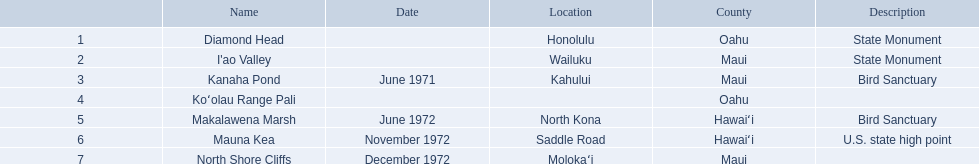What are the names of every landmark? Diamond Head, I'ao Valley, Kanaha Pond, Koʻolau Range Pali, Makalawena Marsh, Mauna Kea, North Shore Cliffs. In which places are they situated? Honolulu, Wailuku, Kahului, , North Kona, Saddle Road, Molokaʻi. And which landmark lacks a listed location? Koʻolau Range Pali. What are the designations of all landmarks? Diamond Head, I'ao Valley, Kanaha Pond, Koʻolau Range Pali, Makalawena Marsh, Mauna Kea, North Shore Cliffs. In which county does each landmark reside? Oahu, Maui, Maui, Oahu, Hawaiʻi, Hawaiʻi, Maui. Apart from mauna kea, which other landmark exists in hawai'i county? Makalawena Marsh. 